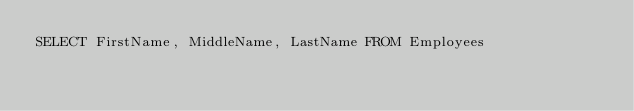Convert code to text. <code><loc_0><loc_0><loc_500><loc_500><_SQL_>SELECT FirstName, MiddleName, LastName FROM Employees</code> 